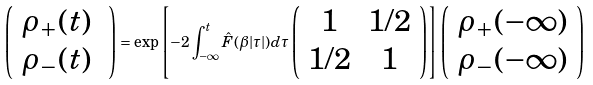<formula> <loc_0><loc_0><loc_500><loc_500>\left ( \begin{array} { l } \rho _ { + } ( t ) \\ \rho _ { - } ( t ) \ \end{array} \right ) = \exp \left [ - 2 \int _ { - \infty } ^ { t } \hat { F } ( \beta | \tau | ) d \tau \left ( \begin{array} { c c } 1 & 1 / 2 \\ 1 / 2 & 1 \end{array} \right ) \right ] \left ( \begin{array} { l } \rho _ { + } ( - \infty ) \\ \rho _ { - } ( - \infty ) \end{array} \right )</formula> 